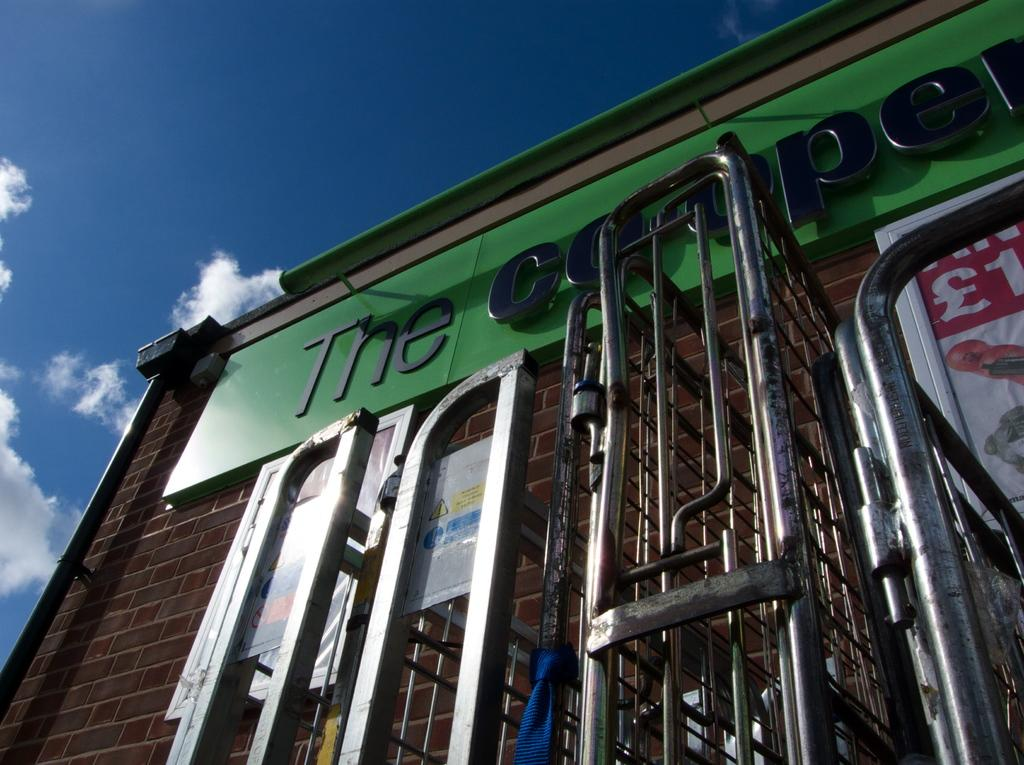<image>
Give a short and clear explanation of the subsequent image. a store front with the number 1 on a advertisement 